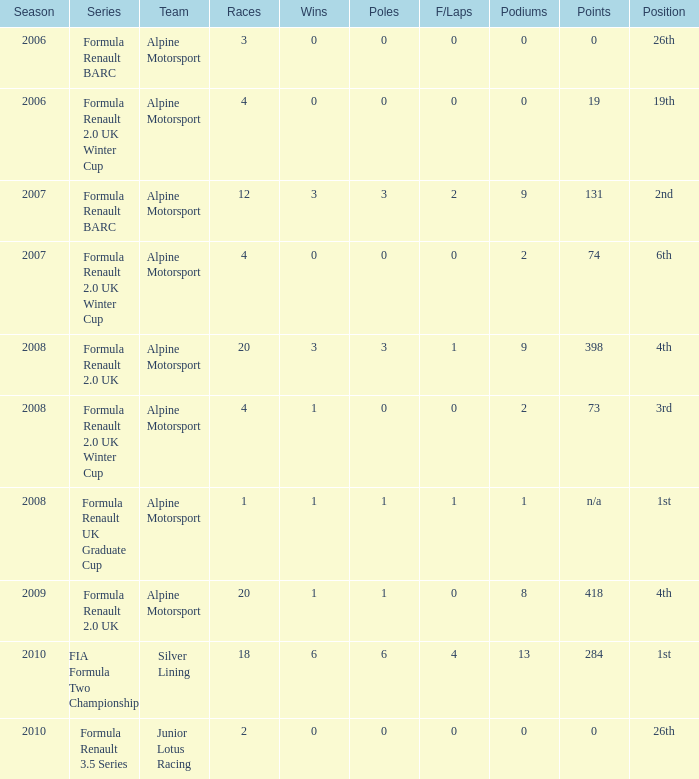What was the first season where the podium count was 9? 2007.0. 